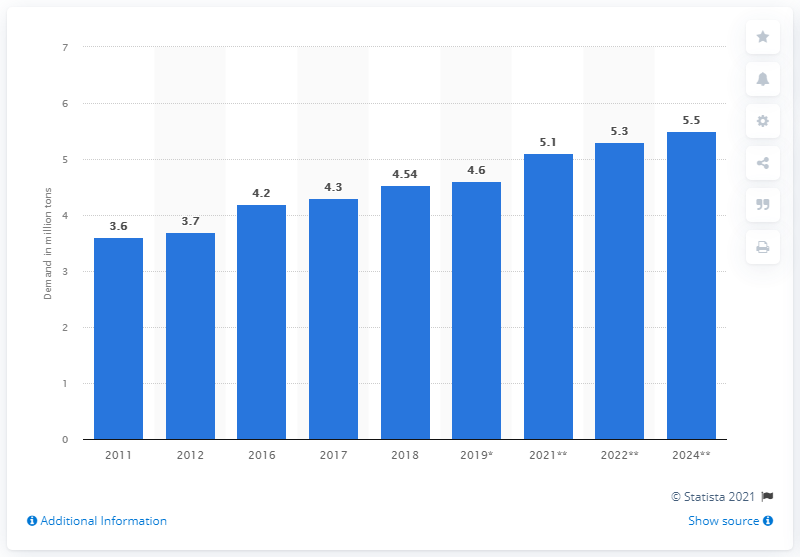Draw attention to some important aspects in this diagram. According to the demand for polycarbonates worldwide in 2011, it was measured at that time. The global demand for polycarbonates is expected to increase significantly by 2024, according to forecasts. In 2019, the global demand for polycarbonates was 4.6 million metric tons. 